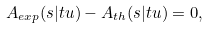<formula> <loc_0><loc_0><loc_500><loc_500>A _ { e x p } ( s | t u ) - A _ { t h } ( s | t u ) = 0 ,</formula> 